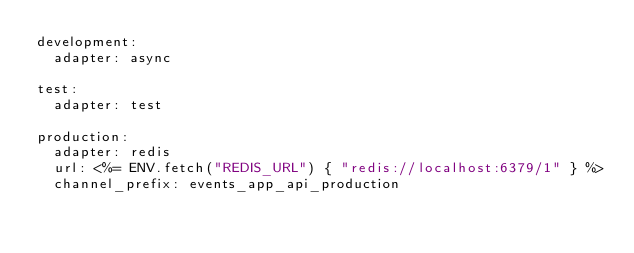<code> <loc_0><loc_0><loc_500><loc_500><_YAML_>development:
  adapter: async

test:
  adapter: test

production:
  adapter: redis
  url: <%= ENV.fetch("REDIS_URL") { "redis://localhost:6379/1" } %>
  channel_prefix: events_app_api_production
</code> 